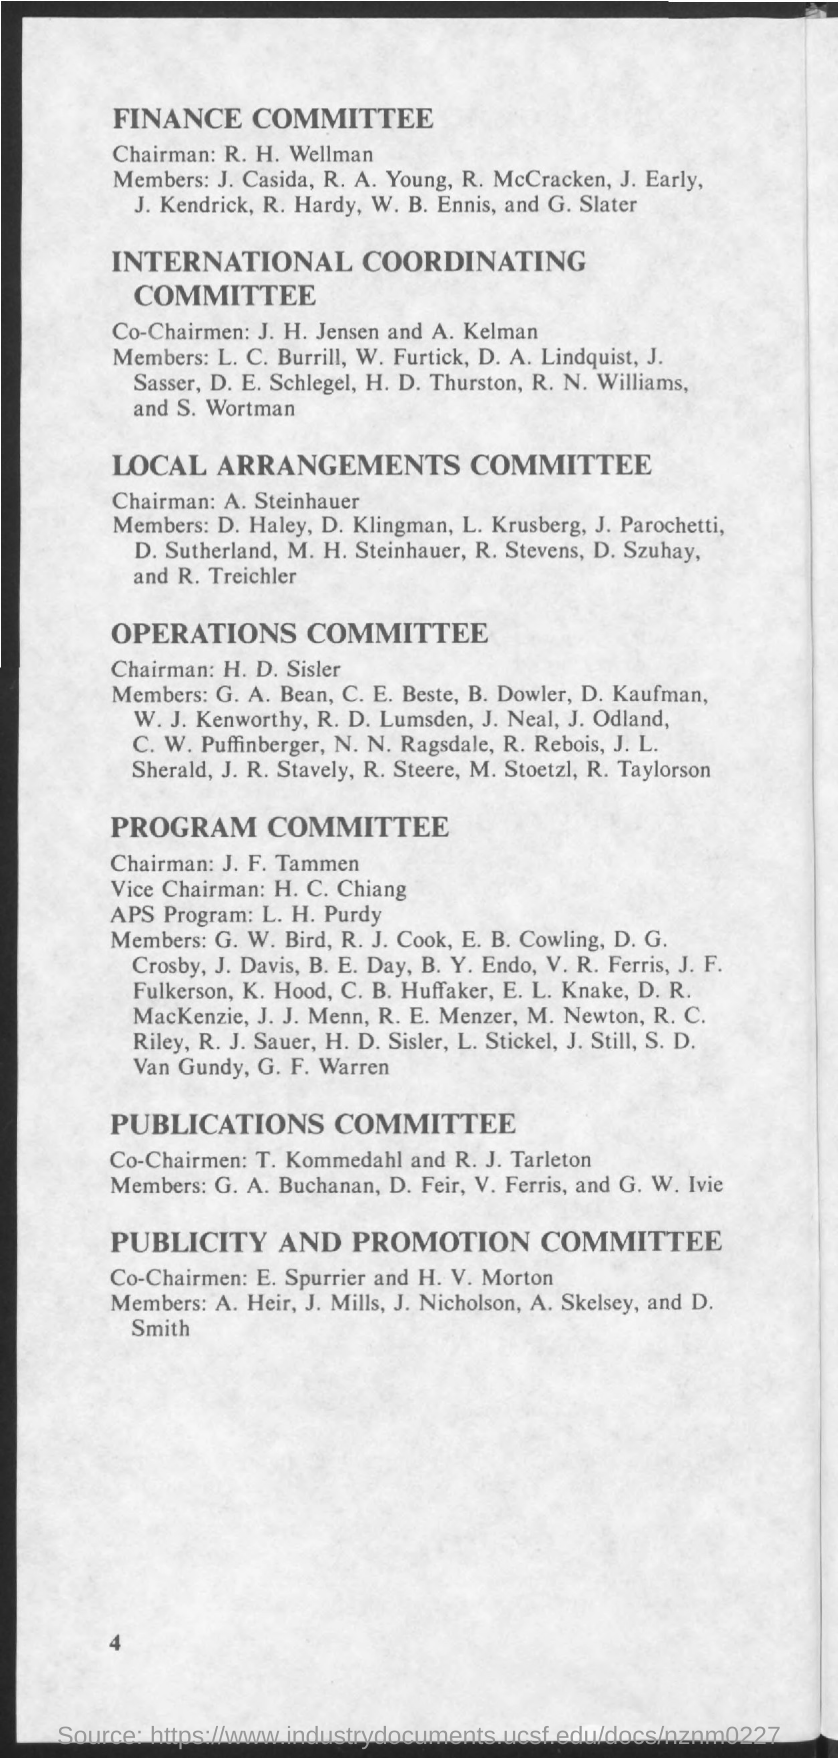Highlight a few significant elements in this photo. In the International Coordinating Committee, John H. Jensen and Abraham Kelman serve as co-chairmen. The chairman of the Finance Committee is Mr. R. H. Wellman. 